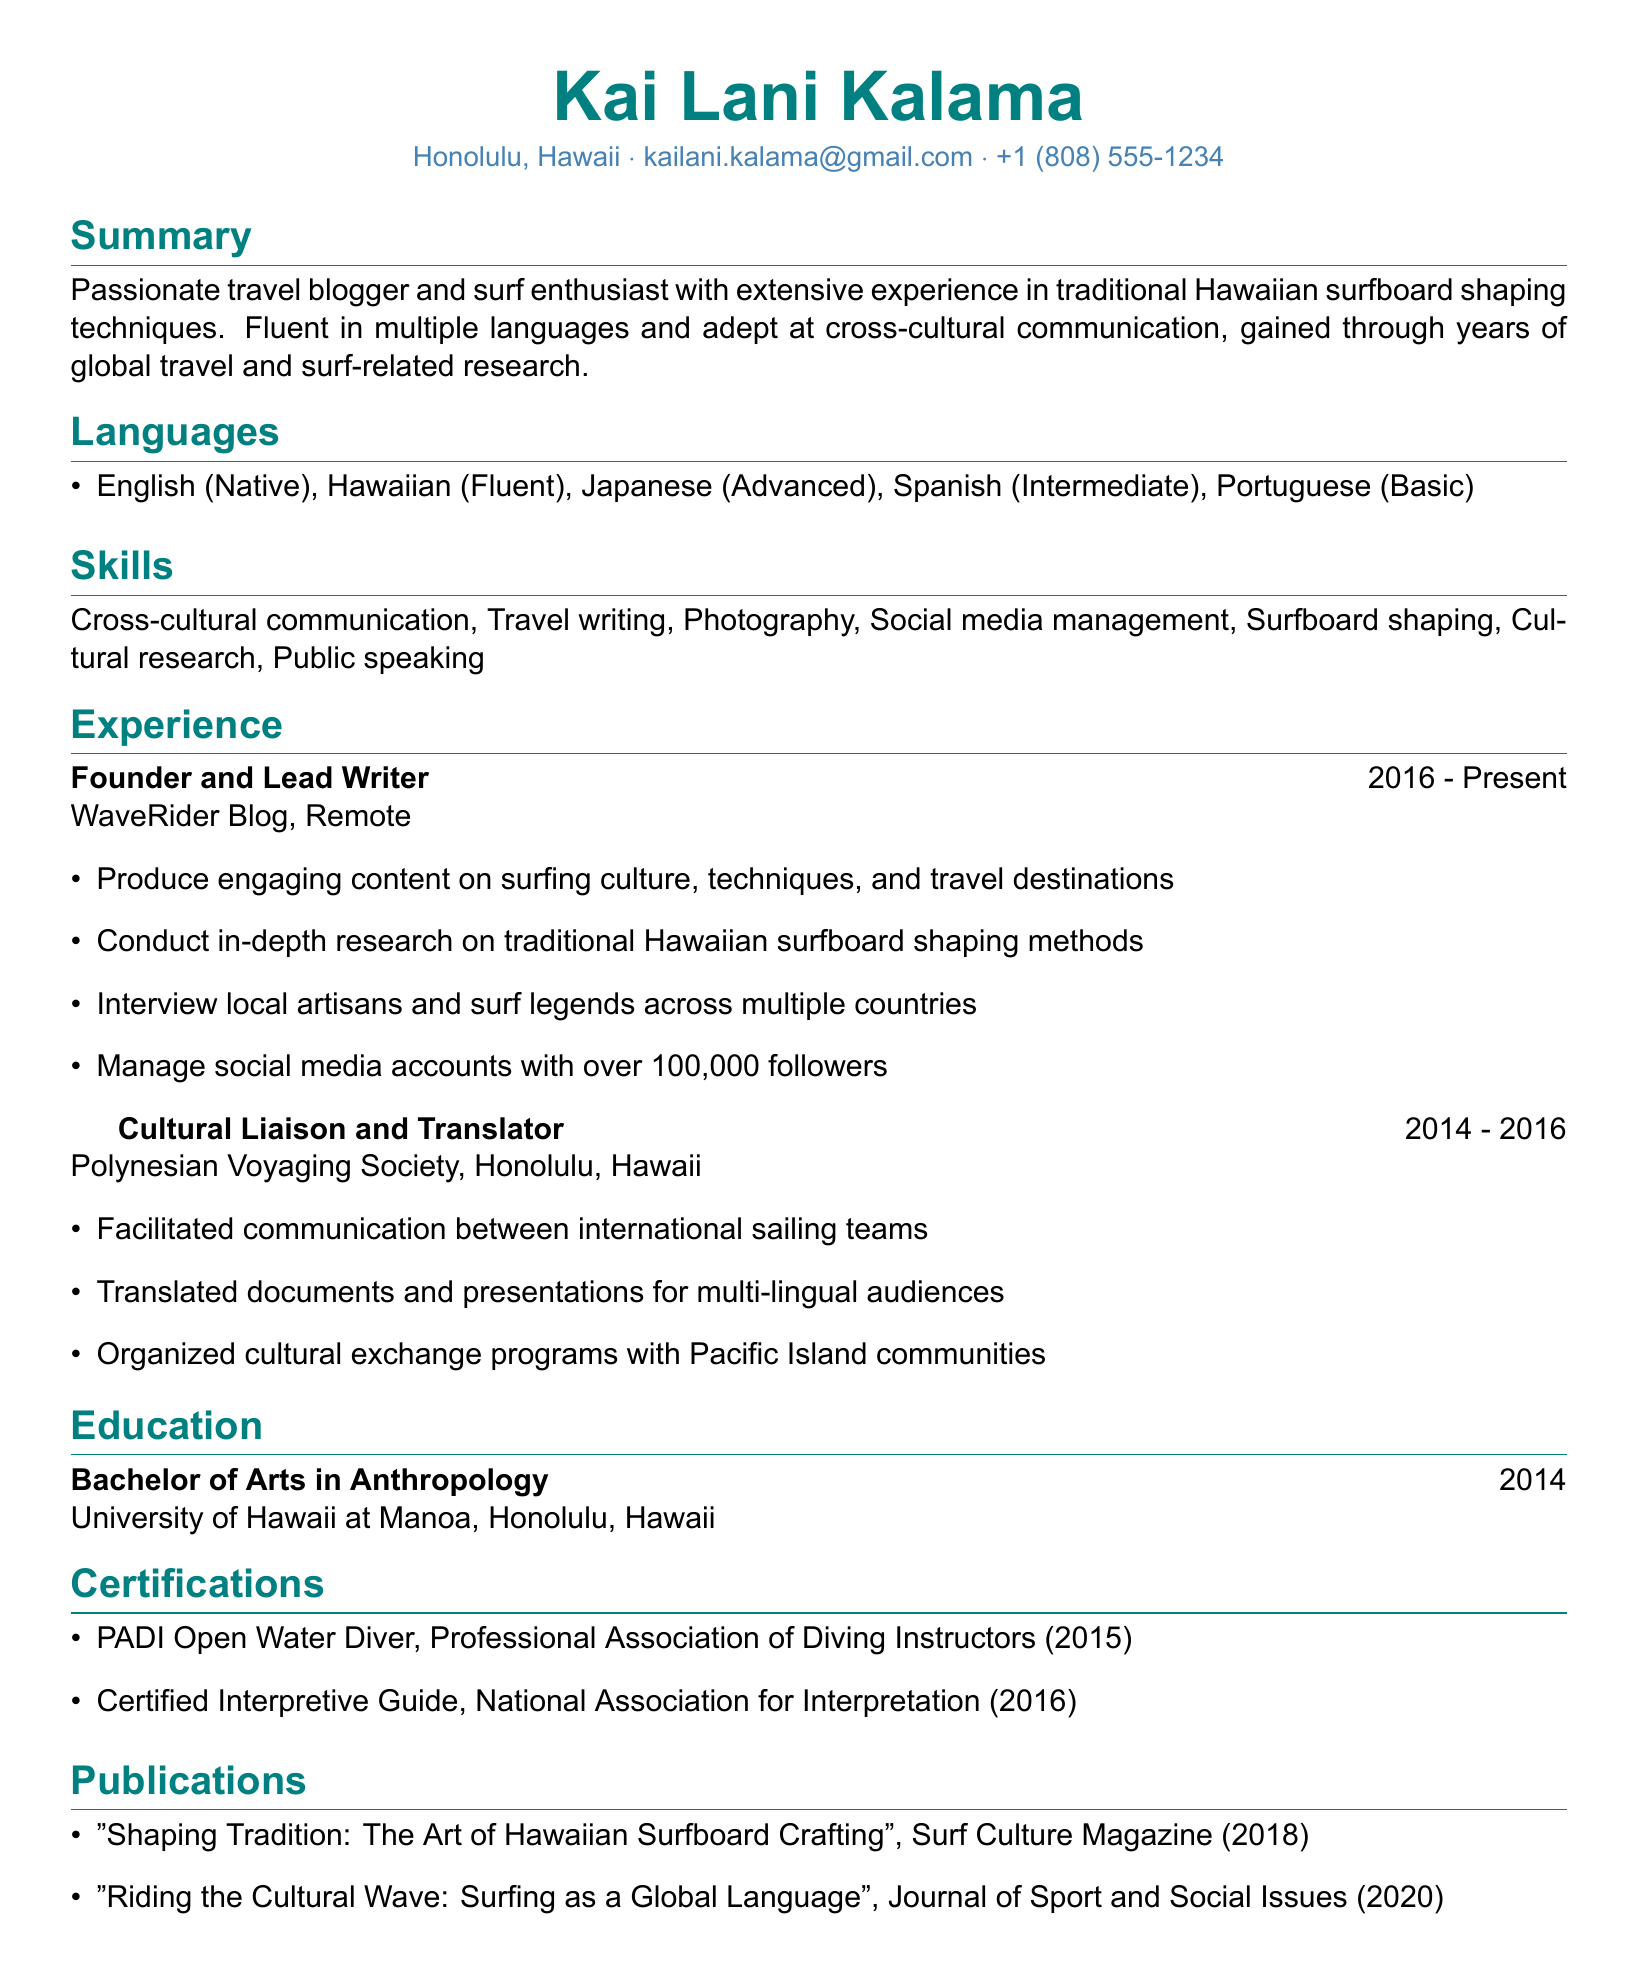What is the name of the founder of WaveRider Blog? The founder of WaveRider Blog is Kai Lani Kalama, as stated in the experience section.
Answer: Kai Lani Kalama In which year did Kai Lani Kalama graduate from university? The graduation year from the University of Hawaii at Manoa is indicated in the education section.
Answer: 2014 What is Kai Lani's proficiency level in Japanese? The proficiency level of Japanese is listed in the languages section.
Answer: Advanced How many languages does Kai Lani speak? The number of languages spoken by Kai Lani can be counted from the languages section.
Answer: Five Which organization did Kai Lani work for as a Cultural Liaison and Translator? The organization for which Kai Lani worked is mentioned in the experience section.
Answer: Polynesian Voyaging Society What type of degree did Kai Lani earn? The degree type is specified in the education section of the document.
Answer: Bachelor of Arts in Anthropology Which magazine published Kai Lani's article on Hawaiian surfboard crafting? The publication 'Surf Culture Magazine' is detailed in the publications section.
Answer: Surf Culture Magazine What skill is highlighted alongside social media management? The skills section includes several skills, and this one is mentioned adjacent to social media management.
Answer: Travel writing 